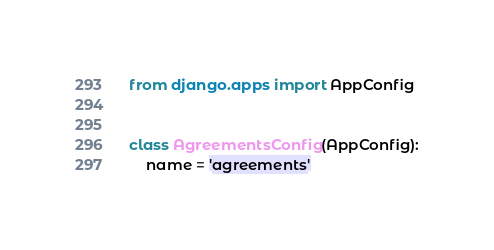<code> <loc_0><loc_0><loc_500><loc_500><_Python_>from django.apps import AppConfig


class AgreementsConfig(AppConfig):
    name = 'agreements'
</code> 